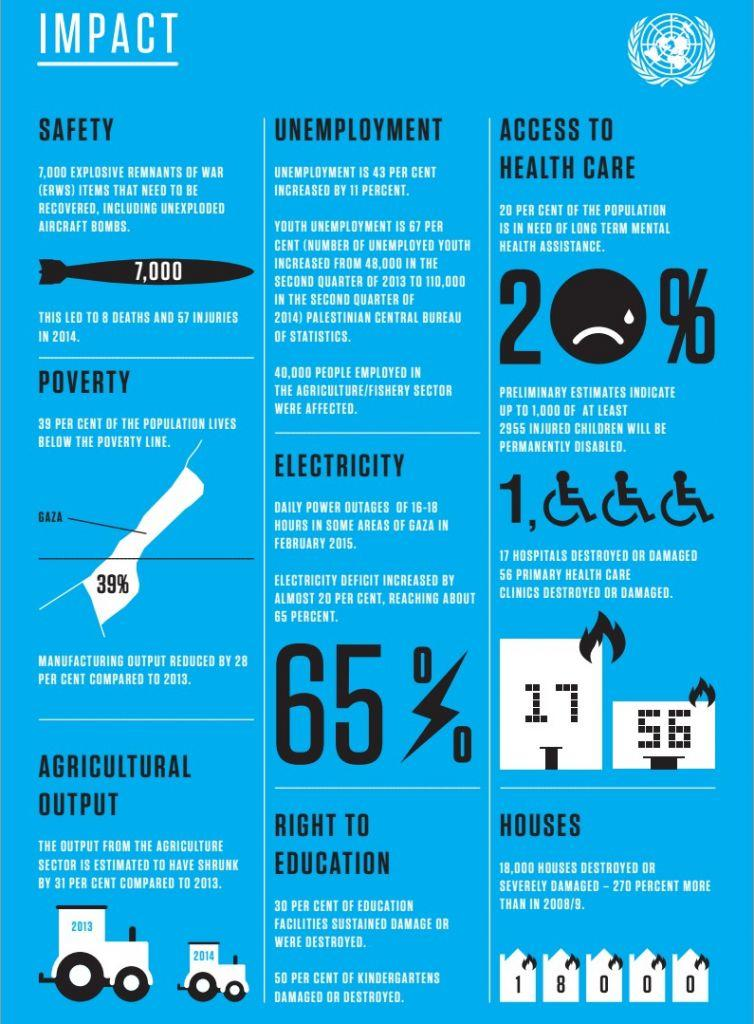List a handful of essential elements in this visual. The unemployment rate increased by 11%. Agricultural output decreased by 31% compared to 2013. It is estimated that 20% of the population require long-term mental health assistance to address their mental health needs. According to the report, approximately 40,000 people in the agriculture and fishing industries were impacted by the disaster. In 2014, 8 deaths were caused by explosive remnants of war. 